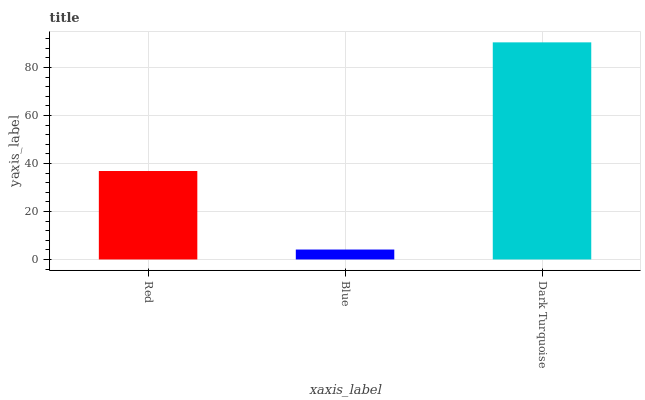Is Blue the minimum?
Answer yes or no. Yes. Is Dark Turquoise the maximum?
Answer yes or no. Yes. Is Dark Turquoise the minimum?
Answer yes or no. No. Is Blue the maximum?
Answer yes or no. No. Is Dark Turquoise greater than Blue?
Answer yes or no. Yes. Is Blue less than Dark Turquoise?
Answer yes or no. Yes. Is Blue greater than Dark Turquoise?
Answer yes or no. No. Is Dark Turquoise less than Blue?
Answer yes or no. No. Is Red the high median?
Answer yes or no. Yes. Is Red the low median?
Answer yes or no. Yes. Is Blue the high median?
Answer yes or no. No. Is Dark Turquoise the low median?
Answer yes or no. No. 